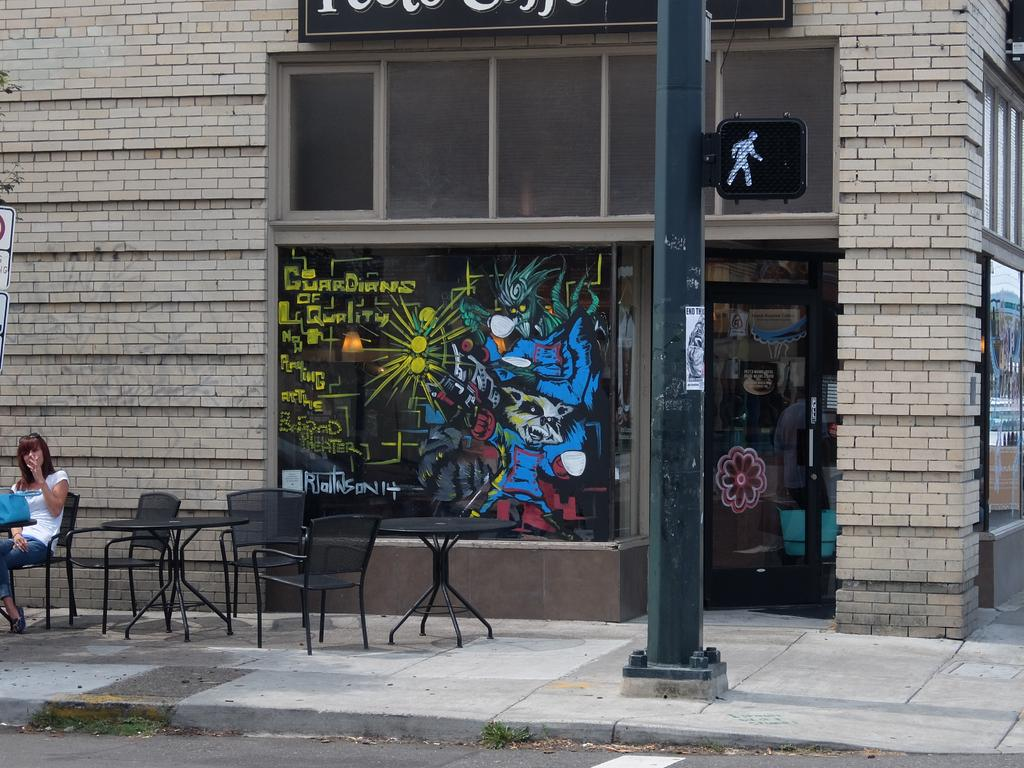What is the woman doing in the image? The woman is sitting on a chair in the image. How many chairs are visible in the image? There are three chairs in the image. How many tables are visible in the image? There are two tables in the image. What type of establishment can be seen in the image? There is a shop visible in the image. What is the tall, vertical object in the image? There is a pole in the image. What is the flat, paved surface in the image? There is a path in the image. What type of cap is the crook wearing in the image? There is no crook or cap present in the image. Can you describe the kitten playing with the pole in the image? There is no kitten or interaction with the pole in the image. 